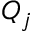Convert formula to latex. <formula><loc_0><loc_0><loc_500><loc_500>Q _ { j }</formula> 